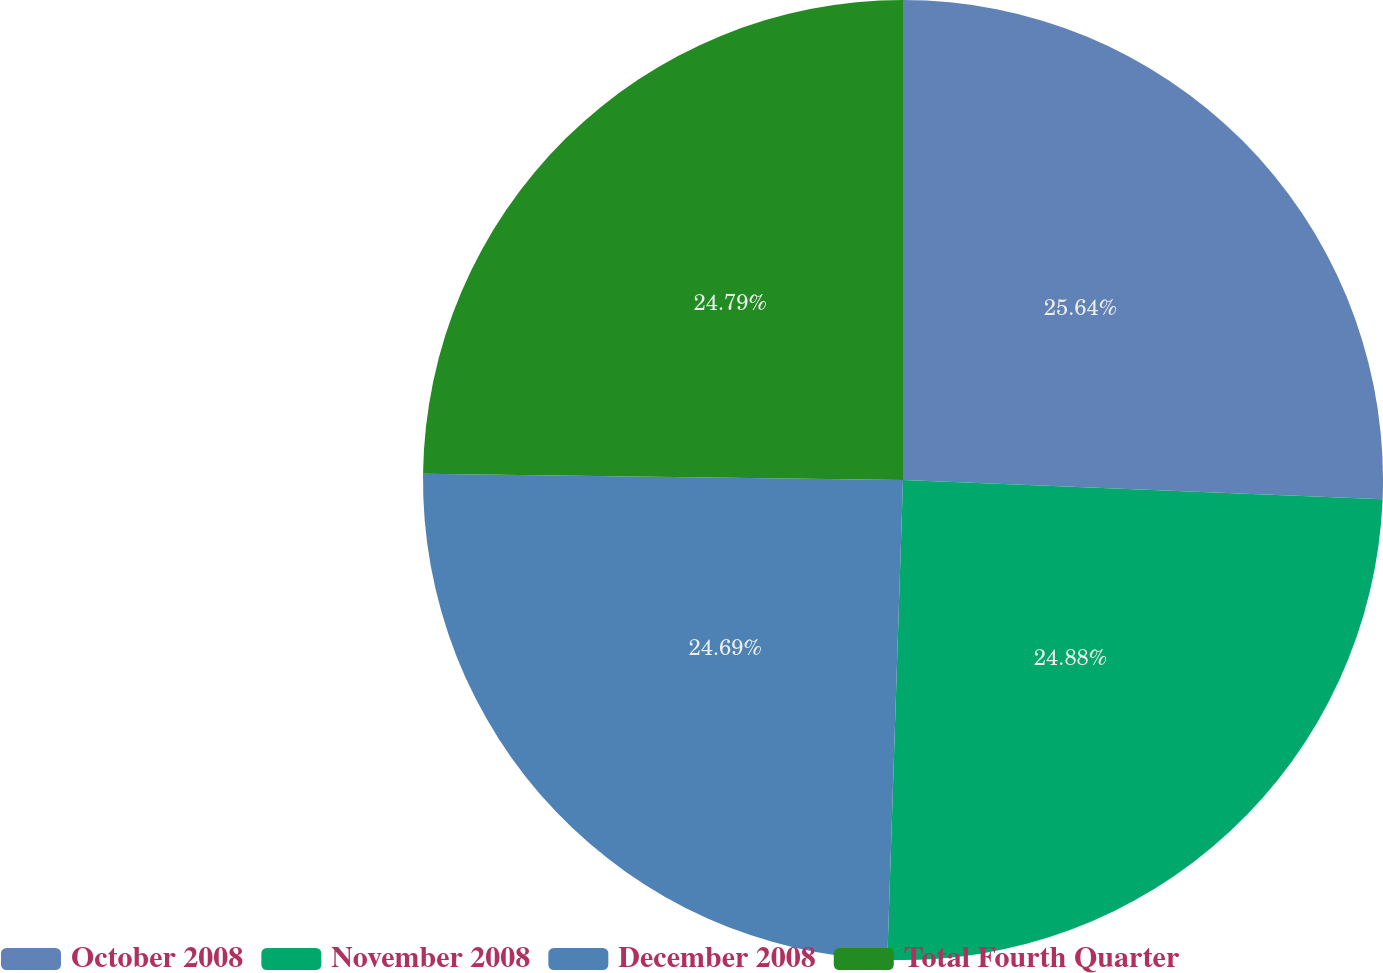<chart> <loc_0><loc_0><loc_500><loc_500><pie_chart><fcel>October 2008<fcel>November 2008<fcel>December 2008<fcel>Total Fourth Quarter<nl><fcel>25.64%<fcel>24.88%<fcel>24.69%<fcel>24.79%<nl></chart> 